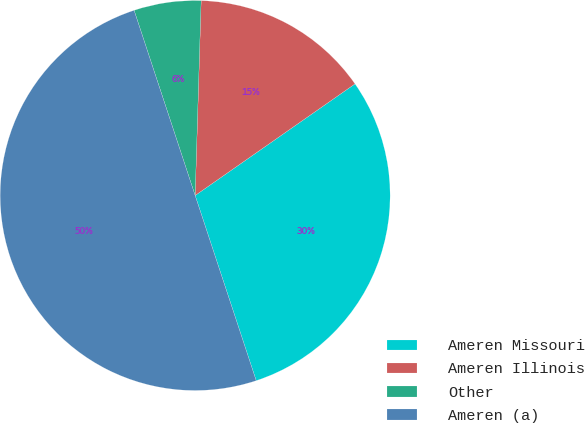Convert chart to OTSL. <chart><loc_0><loc_0><loc_500><loc_500><pie_chart><fcel>Ameren Missouri<fcel>Ameren Illinois<fcel>Other<fcel>Ameren (a)<nl><fcel>29.63%<fcel>14.81%<fcel>5.56%<fcel>50.0%<nl></chart> 